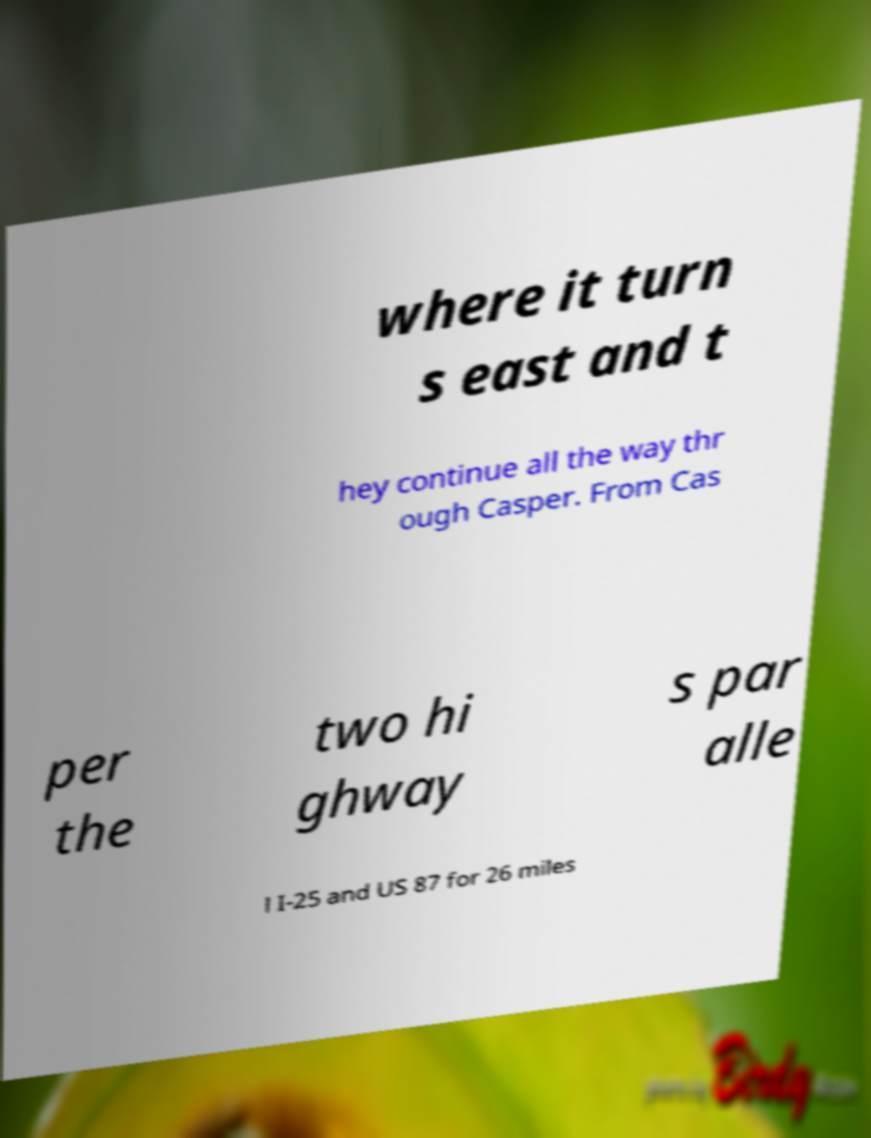Please identify and transcribe the text found in this image. where it turn s east and t hey continue all the way thr ough Casper. From Cas per the two hi ghway s par alle l I-25 and US 87 for 26 miles 